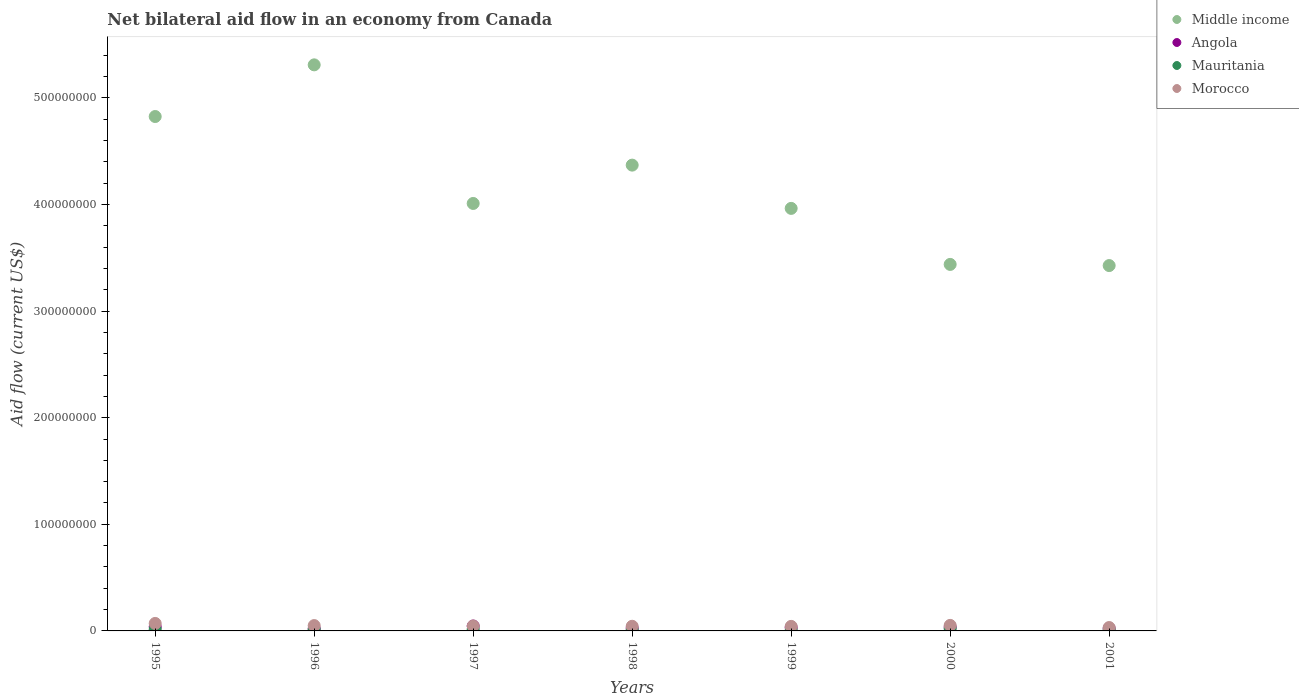What is the net bilateral aid flow in Morocco in 2001?
Your response must be concise. 3.18e+06. Across all years, what is the maximum net bilateral aid flow in Angola?
Your answer should be very brief. 4.59e+06. Across all years, what is the minimum net bilateral aid flow in Angola?
Your answer should be very brief. 2.17e+06. In which year was the net bilateral aid flow in Middle income maximum?
Make the answer very short. 1996. What is the total net bilateral aid flow in Angola in the graph?
Give a very brief answer. 2.23e+07. What is the difference between the net bilateral aid flow in Angola in 1995 and that in 2001?
Ensure brevity in your answer.  1.52e+06. What is the difference between the net bilateral aid flow in Morocco in 1997 and the net bilateral aid flow in Mauritania in 1995?
Offer a very short reply. 3.19e+06. What is the average net bilateral aid flow in Mauritania per year?
Keep it short and to the point. 1.25e+06. In the year 1995, what is the difference between the net bilateral aid flow in Morocco and net bilateral aid flow in Middle income?
Your answer should be compact. -4.75e+08. What is the ratio of the net bilateral aid flow in Middle income in 1997 to that in 2000?
Your answer should be compact. 1.17. Is the net bilateral aid flow in Angola in 1997 less than that in 2001?
Offer a very short reply. No. What is the difference between the highest and the second highest net bilateral aid flow in Middle income?
Your answer should be compact. 4.85e+07. What is the difference between the highest and the lowest net bilateral aid flow in Mauritania?
Provide a succinct answer. 1.61e+06. In how many years, is the net bilateral aid flow in Morocco greater than the average net bilateral aid flow in Morocco taken over all years?
Your answer should be very brief. 3. Is the sum of the net bilateral aid flow in Morocco in 1998 and 2001 greater than the maximum net bilateral aid flow in Angola across all years?
Give a very brief answer. Yes. Is it the case that in every year, the sum of the net bilateral aid flow in Morocco and net bilateral aid flow in Middle income  is greater than the net bilateral aid flow in Mauritania?
Give a very brief answer. Yes. Is the net bilateral aid flow in Middle income strictly greater than the net bilateral aid flow in Morocco over the years?
Give a very brief answer. Yes. How many dotlines are there?
Make the answer very short. 4. Are the values on the major ticks of Y-axis written in scientific E-notation?
Ensure brevity in your answer.  No. Does the graph contain any zero values?
Provide a short and direct response. No. Where does the legend appear in the graph?
Provide a short and direct response. Top right. How are the legend labels stacked?
Provide a succinct answer. Vertical. What is the title of the graph?
Keep it short and to the point. Net bilateral aid flow in an economy from Canada. Does "Spain" appear as one of the legend labels in the graph?
Provide a short and direct response. No. What is the label or title of the X-axis?
Provide a short and direct response. Years. What is the label or title of the Y-axis?
Offer a terse response. Aid flow (current US$). What is the Aid flow (current US$) in Middle income in 1995?
Your answer should be very brief. 4.82e+08. What is the Aid flow (current US$) of Angola in 1995?
Offer a very short reply. 3.84e+06. What is the Aid flow (current US$) of Mauritania in 1995?
Provide a short and direct response. 1.45e+06. What is the Aid flow (current US$) in Morocco in 1995?
Give a very brief answer. 7.02e+06. What is the Aid flow (current US$) in Middle income in 1996?
Give a very brief answer. 5.31e+08. What is the Aid flow (current US$) of Angola in 1996?
Provide a succinct answer. 2.17e+06. What is the Aid flow (current US$) in Mauritania in 1996?
Offer a terse response. 1.30e+06. What is the Aid flow (current US$) of Morocco in 1996?
Your response must be concise. 5.01e+06. What is the Aid flow (current US$) of Middle income in 1997?
Provide a short and direct response. 4.01e+08. What is the Aid flow (current US$) of Angola in 1997?
Your response must be concise. 4.59e+06. What is the Aid flow (current US$) in Mauritania in 1997?
Keep it short and to the point. 1.58e+06. What is the Aid flow (current US$) of Morocco in 1997?
Make the answer very short. 4.64e+06. What is the Aid flow (current US$) in Middle income in 1998?
Keep it short and to the point. 4.37e+08. What is the Aid flow (current US$) of Angola in 1998?
Offer a terse response. 2.63e+06. What is the Aid flow (current US$) in Mauritania in 1998?
Offer a very short reply. 8.80e+05. What is the Aid flow (current US$) of Morocco in 1998?
Keep it short and to the point. 4.36e+06. What is the Aid flow (current US$) of Middle income in 1999?
Make the answer very short. 3.96e+08. What is the Aid flow (current US$) in Angola in 1999?
Ensure brevity in your answer.  3.07e+06. What is the Aid flow (current US$) of Mauritania in 1999?
Offer a terse response. 4.90e+05. What is the Aid flow (current US$) of Morocco in 1999?
Provide a succinct answer. 4.26e+06. What is the Aid flow (current US$) of Middle income in 2000?
Give a very brief answer. 3.44e+08. What is the Aid flow (current US$) of Angola in 2000?
Offer a terse response. 3.64e+06. What is the Aid flow (current US$) of Mauritania in 2000?
Keep it short and to the point. 2.10e+06. What is the Aid flow (current US$) in Morocco in 2000?
Your answer should be compact. 5.19e+06. What is the Aid flow (current US$) of Middle income in 2001?
Provide a succinct answer. 3.43e+08. What is the Aid flow (current US$) in Angola in 2001?
Your answer should be compact. 2.32e+06. What is the Aid flow (current US$) in Mauritania in 2001?
Your response must be concise. 9.60e+05. What is the Aid flow (current US$) of Morocco in 2001?
Offer a terse response. 3.18e+06. Across all years, what is the maximum Aid flow (current US$) in Middle income?
Offer a terse response. 5.31e+08. Across all years, what is the maximum Aid flow (current US$) of Angola?
Ensure brevity in your answer.  4.59e+06. Across all years, what is the maximum Aid flow (current US$) in Mauritania?
Provide a succinct answer. 2.10e+06. Across all years, what is the maximum Aid flow (current US$) in Morocco?
Your answer should be compact. 7.02e+06. Across all years, what is the minimum Aid flow (current US$) in Middle income?
Your answer should be very brief. 3.43e+08. Across all years, what is the minimum Aid flow (current US$) of Angola?
Keep it short and to the point. 2.17e+06. Across all years, what is the minimum Aid flow (current US$) of Mauritania?
Your response must be concise. 4.90e+05. Across all years, what is the minimum Aid flow (current US$) of Morocco?
Provide a succinct answer. 3.18e+06. What is the total Aid flow (current US$) of Middle income in the graph?
Provide a succinct answer. 2.93e+09. What is the total Aid flow (current US$) in Angola in the graph?
Give a very brief answer. 2.23e+07. What is the total Aid flow (current US$) in Mauritania in the graph?
Provide a succinct answer. 8.76e+06. What is the total Aid flow (current US$) of Morocco in the graph?
Provide a short and direct response. 3.37e+07. What is the difference between the Aid flow (current US$) in Middle income in 1995 and that in 1996?
Provide a succinct answer. -4.85e+07. What is the difference between the Aid flow (current US$) of Angola in 1995 and that in 1996?
Offer a very short reply. 1.67e+06. What is the difference between the Aid flow (current US$) of Morocco in 1995 and that in 1996?
Make the answer very short. 2.01e+06. What is the difference between the Aid flow (current US$) of Middle income in 1995 and that in 1997?
Keep it short and to the point. 8.15e+07. What is the difference between the Aid flow (current US$) in Angola in 1995 and that in 1997?
Your answer should be compact. -7.50e+05. What is the difference between the Aid flow (current US$) in Mauritania in 1995 and that in 1997?
Offer a very short reply. -1.30e+05. What is the difference between the Aid flow (current US$) in Morocco in 1995 and that in 1997?
Your answer should be very brief. 2.38e+06. What is the difference between the Aid flow (current US$) of Middle income in 1995 and that in 1998?
Offer a very short reply. 4.56e+07. What is the difference between the Aid flow (current US$) in Angola in 1995 and that in 1998?
Provide a short and direct response. 1.21e+06. What is the difference between the Aid flow (current US$) of Mauritania in 1995 and that in 1998?
Give a very brief answer. 5.70e+05. What is the difference between the Aid flow (current US$) in Morocco in 1995 and that in 1998?
Offer a very short reply. 2.66e+06. What is the difference between the Aid flow (current US$) of Middle income in 1995 and that in 1999?
Your answer should be compact. 8.62e+07. What is the difference between the Aid flow (current US$) in Angola in 1995 and that in 1999?
Offer a very short reply. 7.70e+05. What is the difference between the Aid flow (current US$) in Mauritania in 1995 and that in 1999?
Offer a very short reply. 9.60e+05. What is the difference between the Aid flow (current US$) of Morocco in 1995 and that in 1999?
Your response must be concise. 2.76e+06. What is the difference between the Aid flow (current US$) in Middle income in 1995 and that in 2000?
Ensure brevity in your answer.  1.39e+08. What is the difference between the Aid flow (current US$) in Mauritania in 1995 and that in 2000?
Your answer should be compact. -6.50e+05. What is the difference between the Aid flow (current US$) in Morocco in 1995 and that in 2000?
Your answer should be very brief. 1.83e+06. What is the difference between the Aid flow (current US$) of Middle income in 1995 and that in 2001?
Your response must be concise. 1.40e+08. What is the difference between the Aid flow (current US$) in Angola in 1995 and that in 2001?
Offer a terse response. 1.52e+06. What is the difference between the Aid flow (current US$) of Mauritania in 1995 and that in 2001?
Your answer should be compact. 4.90e+05. What is the difference between the Aid flow (current US$) of Morocco in 1995 and that in 2001?
Your answer should be very brief. 3.84e+06. What is the difference between the Aid flow (current US$) in Middle income in 1996 and that in 1997?
Your answer should be compact. 1.30e+08. What is the difference between the Aid flow (current US$) of Angola in 1996 and that in 1997?
Your answer should be compact. -2.42e+06. What is the difference between the Aid flow (current US$) of Mauritania in 1996 and that in 1997?
Ensure brevity in your answer.  -2.80e+05. What is the difference between the Aid flow (current US$) of Morocco in 1996 and that in 1997?
Your response must be concise. 3.70e+05. What is the difference between the Aid flow (current US$) of Middle income in 1996 and that in 1998?
Keep it short and to the point. 9.40e+07. What is the difference between the Aid flow (current US$) of Angola in 1996 and that in 1998?
Provide a succinct answer. -4.60e+05. What is the difference between the Aid flow (current US$) in Morocco in 1996 and that in 1998?
Make the answer very short. 6.50e+05. What is the difference between the Aid flow (current US$) of Middle income in 1996 and that in 1999?
Provide a short and direct response. 1.35e+08. What is the difference between the Aid flow (current US$) of Angola in 1996 and that in 1999?
Your response must be concise. -9.00e+05. What is the difference between the Aid flow (current US$) of Mauritania in 1996 and that in 1999?
Offer a very short reply. 8.10e+05. What is the difference between the Aid flow (current US$) in Morocco in 1996 and that in 1999?
Your answer should be very brief. 7.50e+05. What is the difference between the Aid flow (current US$) of Middle income in 1996 and that in 2000?
Make the answer very short. 1.87e+08. What is the difference between the Aid flow (current US$) in Angola in 1996 and that in 2000?
Offer a very short reply. -1.47e+06. What is the difference between the Aid flow (current US$) of Mauritania in 1996 and that in 2000?
Offer a very short reply. -8.00e+05. What is the difference between the Aid flow (current US$) of Middle income in 1996 and that in 2001?
Your answer should be very brief. 1.88e+08. What is the difference between the Aid flow (current US$) of Mauritania in 1996 and that in 2001?
Your response must be concise. 3.40e+05. What is the difference between the Aid flow (current US$) of Morocco in 1996 and that in 2001?
Make the answer very short. 1.83e+06. What is the difference between the Aid flow (current US$) in Middle income in 1997 and that in 1998?
Provide a succinct answer. -3.60e+07. What is the difference between the Aid flow (current US$) of Angola in 1997 and that in 1998?
Your answer should be compact. 1.96e+06. What is the difference between the Aid flow (current US$) of Morocco in 1997 and that in 1998?
Give a very brief answer. 2.80e+05. What is the difference between the Aid flow (current US$) in Middle income in 1997 and that in 1999?
Offer a very short reply. 4.63e+06. What is the difference between the Aid flow (current US$) of Angola in 1997 and that in 1999?
Keep it short and to the point. 1.52e+06. What is the difference between the Aid flow (current US$) of Mauritania in 1997 and that in 1999?
Your answer should be very brief. 1.09e+06. What is the difference between the Aid flow (current US$) of Morocco in 1997 and that in 1999?
Offer a terse response. 3.80e+05. What is the difference between the Aid flow (current US$) of Middle income in 1997 and that in 2000?
Keep it short and to the point. 5.72e+07. What is the difference between the Aid flow (current US$) in Angola in 1997 and that in 2000?
Your answer should be very brief. 9.50e+05. What is the difference between the Aid flow (current US$) of Mauritania in 1997 and that in 2000?
Your answer should be compact. -5.20e+05. What is the difference between the Aid flow (current US$) of Morocco in 1997 and that in 2000?
Provide a succinct answer. -5.50e+05. What is the difference between the Aid flow (current US$) of Middle income in 1997 and that in 2001?
Offer a terse response. 5.83e+07. What is the difference between the Aid flow (current US$) of Angola in 1997 and that in 2001?
Provide a short and direct response. 2.27e+06. What is the difference between the Aid flow (current US$) in Mauritania in 1997 and that in 2001?
Offer a terse response. 6.20e+05. What is the difference between the Aid flow (current US$) in Morocco in 1997 and that in 2001?
Give a very brief answer. 1.46e+06. What is the difference between the Aid flow (current US$) of Middle income in 1998 and that in 1999?
Make the answer very short. 4.06e+07. What is the difference between the Aid flow (current US$) of Angola in 1998 and that in 1999?
Offer a very short reply. -4.40e+05. What is the difference between the Aid flow (current US$) of Middle income in 1998 and that in 2000?
Provide a short and direct response. 9.31e+07. What is the difference between the Aid flow (current US$) in Angola in 1998 and that in 2000?
Provide a short and direct response. -1.01e+06. What is the difference between the Aid flow (current US$) in Mauritania in 1998 and that in 2000?
Your answer should be very brief. -1.22e+06. What is the difference between the Aid flow (current US$) in Morocco in 1998 and that in 2000?
Provide a succinct answer. -8.30e+05. What is the difference between the Aid flow (current US$) of Middle income in 1998 and that in 2001?
Make the answer very short. 9.42e+07. What is the difference between the Aid flow (current US$) in Morocco in 1998 and that in 2001?
Your answer should be very brief. 1.18e+06. What is the difference between the Aid flow (current US$) in Middle income in 1999 and that in 2000?
Provide a succinct answer. 5.26e+07. What is the difference between the Aid flow (current US$) in Angola in 1999 and that in 2000?
Provide a short and direct response. -5.70e+05. What is the difference between the Aid flow (current US$) in Mauritania in 1999 and that in 2000?
Make the answer very short. -1.61e+06. What is the difference between the Aid flow (current US$) of Morocco in 1999 and that in 2000?
Ensure brevity in your answer.  -9.30e+05. What is the difference between the Aid flow (current US$) in Middle income in 1999 and that in 2001?
Your answer should be very brief. 5.36e+07. What is the difference between the Aid flow (current US$) of Angola in 1999 and that in 2001?
Your answer should be compact. 7.50e+05. What is the difference between the Aid flow (current US$) of Mauritania in 1999 and that in 2001?
Ensure brevity in your answer.  -4.70e+05. What is the difference between the Aid flow (current US$) of Morocco in 1999 and that in 2001?
Provide a short and direct response. 1.08e+06. What is the difference between the Aid flow (current US$) of Middle income in 2000 and that in 2001?
Offer a terse response. 1.08e+06. What is the difference between the Aid flow (current US$) in Angola in 2000 and that in 2001?
Offer a terse response. 1.32e+06. What is the difference between the Aid flow (current US$) in Mauritania in 2000 and that in 2001?
Offer a very short reply. 1.14e+06. What is the difference between the Aid flow (current US$) of Morocco in 2000 and that in 2001?
Your answer should be compact. 2.01e+06. What is the difference between the Aid flow (current US$) of Middle income in 1995 and the Aid flow (current US$) of Angola in 1996?
Provide a succinct answer. 4.80e+08. What is the difference between the Aid flow (current US$) of Middle income in 1995 and the Aid flow (current US$) of Mauritania in 1996?
Give a very brief answer. 4.81e+08. What is the difference between the Aid flow (current US$) in Middle income in 1995 and the Aid flow (current US$) in Morocco in 1996?
Provide a short and direct response. 4.77e+08. What is the difference between the Aid flow (current US$) of Angola in 1995 and the Aid flow (current US$) of Mauritania in 1996?
Keep it short and to the point. 2.54e+06. What is the difference between the Aid flow (current US$) in Angola in 1995 and the Aid flow (current US$) in Morocco in 1996?
Give a very brief answer. -1.17e+06. What is the difference between the Aid flow (current US$) of Mauritania in 1995 and the Aid flow (current US$) of Morocco in 1996?
Keep it short and to the point. -3.56e+06. What is the difference between the Aid flow (current US$) of Middle income in 1995 and the Aid flow (current US$) of Angola in 1997?
Your response must be concise. 4.78e+08. What is the difference between the Aid flow (current US$) in Middle income in 1995 and the Aid flow (current US$) in Mauritania in 1997?
Your answer should be very brief. 4.81e+08. What is the difference between the Aid flow (current US$) in Middle income in 1995 and the Aid flow (current US$) in Morocco in 1997?
Your answer should be compact. 4.78e+08. What is the difference between the Aid flow (current US$) of Angola in 1995 and the Aid flow (current US$) of Mauritania in 1997?
Your answer should be compact. 2.26e+06. What is the difference between the Aid flow (current US$) of Angola in 1995 and the Aid flow (current US$) of Morocco in 1997?
Give a very brief answer. -8.00e+05. What is the difference between the Aid flow (current US$) of Mauritania in 1995 and the Aid flow (current US$) of Morocco in 1997?
Keep it short and to the point. -3.19e+06. What is the difference between the Aid flow (current US$) of Middle income in 1995 and the Aid flow (current US$) of Angola in 1998?
Offer a terse response. 4.80e+08. What is the difference between the Aid flow (current US$) of Middle income in 1995 and the Aid flow (current US$) of Mauritania in 1998?
Make the answer very short. 4.82e+08. What is the difference between the Aid flow (current US$) in Middle income in 1995 and the Aid flow (current US$) in Morocco in 1998?
Keep it short and to the point. 4.78e+08. What is the difference between the Aid flow (current US$) in Angola in 1995 and the Aid flow (current US$) in Mauritania in 1998?
Keep it short and to the point. 2.96e+06. What is the difference between the Aid flow (current US$) in Angola in 1995 and the Aid flow (current US$) in Morocco in 1998?
Provide a succinct answer. -5.20e+05. What is the difference between the Aid flow (current US$) in Mauritania in 1995 and the Aid flow (current US$) in Morocco in 1998?
Make the answer very short. -2.91e+06. What is the difference between the Aid flow (current US$) of Middle income in 1995 and the Aid flow (current US$) of Angola in 1999?
Provide a short and direct response. 4.79e+08. What is the difference between the Aid flow (current US$) of Middle income in 1995 and the Aid flow (current US$) of Mauritania in 1999?
Keep it short and to the point. 4.82e+08. What is the difference between the Aid flow (current US$) of Middle income in 1995 and the Aid flow (current US$) of Morocco in 1999?
Provide a short and direct response. 4.78e+08. What is the difference between the Aid flow (current US$) of Angola in 1995 and the Aid flow (current US$) of Mauritania in 1999?
Provide a succinct answer. 3.35e+06. What is the difference between the Aid flow (current US$) of Angola in 1995 and the Aid flow (current US$) of Morocco in 1999?
Give a very brief answer. -4.20e+05. What is the difference between the Aid flow (current US$) in Mauritania in 1995 and the Aid flow (current US$) in Morocco in 1999?
Offer a terse response. -2.81e+06. What is the difference between the Aid flow (current US$) of Middle income in 1995 and the Aid flow (current US$) of Angola in 2000?
Provide a short and direct response. 4.79e+08. What is the difference between the Aid flow (current US$) of Middle income in 1995 and the Aid flow (current US$) of Mauritania in 2000?
Offer a very short reply. 4.80e+08. What is the difference between the Aid flow (current US$) of Middle income in 1995 and the Aid flow (current US$) of Morocco in 2000?
Give a very brief answer. 4.77e+08. What is the difference between the Aid flow (current US$) of Angola in 1995 and the Aid flow (current US$) of Mauritania in 2000?
Give a very brief answer. 1.74e+06. What is the difference between the Aid flow (current US$) of Angola in 1995 and the Aid flow (current US$) of Morocco in 2000?
Provide a succinct answer. -1.35e+06. What is the difference between the Aid flow (current US$) in Mauritania in 1995 and the Aid flow (current US$) in Morocco in 2000?
Ensure brevity in your answer.  -3.74e+06. What is the difference between the Aid flow (current US$) in Middle income in 1995 and the Aid flow (current US$) in Angola in 2001?
Your response must be concise. 4.80e+08. What is the difference between the Aid flow (current US$) of Middle income in 1995 and the Aid flow (current US$) of Mauritania in 2001?
Your answer should be compact. 4.82e+08. What is the difference between the Aid flow (current US$) of Middle income in 1995 and the Aid flow (current US$) of Morocco in 2001?
Offer a very short reply. 4.79e+08. What is the difference between the Aid flow (current US$) of Angola in 1995 and the Aid flow (current US$) of Mauritania in 2001?
Offer a terse response. 2.88e+06. What is the difference between the Aid flow (current US$) in Angola in 1995 and the Aid flow (current US$) in Morocco in 2001?
Your answer should be very brief. 6.60e+05. What is the difference between the Aid flow (current US$) of Mauritania in 1995 and the Aid flow (current US$) of Morocco in 2001?
Keep it short and to the point. -1.73e+06. What is the difference between the Aid flow (current US$) of Middle income in 1996 and the Aid flow (current US$) of Angola in 1997?
Your answer should be compact. 5.26e+08. What is the difference between the Aid flow (current US$) of Middle income in 1996 and the Aid flow (current US$) of Mauritania in 1997?
Provide a short and direct response. 5.29e+08. What is the difference between the Aid flow (current US$) in Middle income in 1996 and the Aid flow (current US$) in Morocco in 1997?
Ensure brevity in your answer.  5.26e+08. What is the difference between the Aid flow (current US$) in Angola in 1996 and the Aid flow (current US$) in Mauritania in 1997?
Offer a terse response. 5.90e+05. What is the difference between the Aid flow (current US$) in Angola in 1996 and the Aid flow (current US$) in Morocco in 1997?
Provide a short and direct response. -2.47e+06. What is the difference between the Aid flow (current US$) of Mauritania in 1996 and the Aid flow (current US$) of Morocco in 1997?
Ensure brevity in your answer.  -3.34e+06. What is the difference between the Aid flow (current US$) of Middle income in 1996 and the Aid flow (current US$) of Angola in 1998?
Offer a very short reply. 5.28e+08. What is the difference between the Aid flow (current US$) of Middle income in 1996 and the Aid flow (current US$) of Mauritania in 1998?
Ensure brevity in your answer.  5.30e+08. What is the difference between the Aid flow (current US$) of Middle income in 1996 and the Aid flow (current US$) of Morocco in 1998?
Give a very brief answer. 5.27e+08. What is the difference between the Aid flow (current US$) in Angola in 1996 and the Aid flow (current US$) in Mauritania in 1998?
Offer a terse response. 1.29e+06. What is the difference between the Aid flow (current US$) of Angola in 1996 and the Aid flow (current US$) of Morocco in 1998?
Make the answer very short. -2.19e+06. What is the difference between the Aid flow (current US$) in Mauritania in 1996 and the Aid flow (current US$) in Morocco in 1998?
Provide a short and direct response. -3.06e+06. What is the difference between the Aid flow (current US$) in Middle income in 1996 and the Aid flow (current US$) in Angola in 1999?
Give a very brief answer. 5.28e+08. What is the difference between the Aid flow (current US$) of Middle income in 1996 and the Aid flow (current US$) of Mauritania in 1999?
Give a very brief answer. 5.30e+08. What is the difference between the Aid flow (current US$) in Middle income in 1996 and the Aid flow (current US$) in Morocco in 1999?
Ensure brevity in your answer.  5.27e+08. What is the difference between the Aid flow (current US$) of Angola in 1996 and the Aid flow (current US$) of Mauritania in 1999?
Offer a very short reply. 1.68e+06. What is the difference between the Aid flow (current US$) of Angola in 1996 and the Aid flow (current US$) of Morocco in 1999?
Offer a very short reply. -2.09e+06. What is the difference between the Aid flow (current US$) of Mauritania in 1996 and the Aid flow (current US$) of Morocco in 1999?
Make the answer very short. -2.96e+06. What is the difference between the Aid flow (current US$) in Middle income in 1996 and the Aid flow (current US$) in Angola in 2000?
Ensure brevity in your answer.  5.27e+08. What is the difference between the Aid flow (current US$) of Middle income in 1996 and the Aid flow (current US$) of Mauritania in 2000?
Ensure brevity in your answer.  5.29e+08. What is the difference between the Aid flow (current US$) of Middle income in 1996 and the Aid flow (current US$) of Morocco in 2000?
Ensure brevity in your answer.  5.26e+08. What is the difference between the Aid flow (current US$) of Angola in 1996 and the Aid flow (current US$) of Morocco in 2000?
Your response must be concise. -3.02e+06. What is the difference between the Aid flow (current US$) of Mauritania in 1996 and the Aid flow (current US$) of Morocco in 2000?
Offer a terse response. -3.89e+06. What is the difference between the Aid flow (current US$) in Middle income in 1996 and the Aid flow (current US$) in Angola in 2001?
Keep it short and to the point. 5.29e+08. What is the difference between the Aid flow (current US$) of Middle income in 1996 and the Aid flow (current US$) of Mauritania in 2001?
Your answer should be very brief. 5.30e+08. What is the difference between the Aid flow (current US$) of Middle income in 1996 and the Aid flow (current US$) of Morocco in 2001?
Provide a short and direct response. 5.28e+08. What is the difference between the Aid flow (current US$) of Angola in 1996 and the Aid flow (current US$) of Mauritania in 2001?
Your answer should be compact. 1.21e+06. What is the difference between the Aid flow (current US$) in Angola in 1996 and the Aid flow (current US$) in Morocco in 2001?
Give a very brief answer. -1.01e+06. What is the difference between the Aid flow (current US$) in Mauritania in 1996 and the Aid flow (current US$) in Morocco in 2001?
Your response must be concise. -1.88e+06. What is the difference between the Aid flow (current US$) in Middle income in 1997 and the Aid flow (current US$) in Angola in 1998?
Offer a very short reply. 3.98e+08. What is the difference between the Aid flow (current US$) in Middle income in 1997 and the Aid flow (current US$) in Mauritania in 1998?
Provide a succinct answer. 4.00e+08. What is the difference between the Aid flow (current US$) in Middle income in 1997 and the Aid flow (current US$) in Morocco in 1998?
Offer a terse response. 3.97e+08. What is the difference between the Aid flow (current US$) in Angola in 1997 and the Aid flow (current US$) in Mauritania in 1998?
Keep it short and to the point. 3.71e+06. What is the difference between the Aid flow (current US$) in Angola in 1997 and the Aid flow (current US$) in Morocco in 1998?
Your response must be concise. 2.30e+05. What is the difference between the Aid flow (current US$) in Mauritania in 1997 and the Aid flow (current US$) in Morocco in 1998?
Provide a short and direct response. -2.78e+06. What is the difference between the Aid flow (current US$) in Middle income in 1997 and the Aid flow (current US$) in Angola in 1999?
Give a very brief answer. 3.98e+08. What is the difference between the Aid flow (current US$) of Middle income in 1997 and the Aid flow (current US$) of Mauritania in 1999?
Offer a terse response. 4.00e+08. What is the difference between the Aid flow (current US$) of Middle income in 1997 and the Aid flow (current US$) of Morocco in 1999?
Provide a succinct answer. 3.97e+08. What is the difference between the Aid flow (current US$) in Angola in 1997 and the Aid flow (current US$) in Mauritania in 1999?
Offer a very short reply. 4.10e+06. What is the difference between the Aid flow (current US$) in Angola in 1997 and the Aid flow (current US$) in Morocco in 1999?
Your answer should be compact. 3.30e+05. What is the difference between the Aid flow (current US$) in Mauritania in 1997 and the Aid flow (current US$) in Morocco in 1999?
Your answer should be very brief. -2.68e+06. What is the difference between the Aid flow (current US$) in Middle income in 1997 and the Aid flow (current US$) in Angola in 2000?
Your answer should be very brief. 3.97e+08. What is the difference between the Aid flow (current US$) in Middle income in 1997 and the Aid flow (current US$) in Mauritania in 2000?
Provide a succinct answer. 3.99e+08. What is the difference between the Aid flow (current US$) in Middle income in 1997 and the Aid flow (current US$) in Morocco in 2000?
Offer a very short reply. 3.96e+08. What is the difference between the Aid flow (current US$) in Angola in 1997 and the Aid flow (current US$) in Mauritania in 2000?
Provide a succinct answer. 2.49e+06. What is the difference between the Aid flow (current US$) in Angola in 1997 and the Aid flow (current US$) in Morocco in 2000?
Offer a terse response. -6.00e+05. What is the difference between the Aid flow (current US$) of Mauritania in 1997 and the Aid flow (current US$) of Morocco in 2000?
Your response must be concise. -3.61e+06. What is the difference between the Aid flow (current US$) in Middle income in 1997 and the Aid flow (current US$) in Angola in 2001?
Ensure brevity in your answer.  3.99e+08. What is the difference between the Aid flow (current US$) in Middle income in 1997 and the Aid flow (current US$) in Mauritania in 2001?
Keep it short and to the point. 4.00e+08. What is the difference between the Aid flow (current US$) of Middle income in 1997 and the Aid flow (current US$) of Morocco in 2001?
Your answer should be very brief. 3.98e+08. What is the difference between the Aid flow (current US$) of Angola in 1997 and the Aid flow (current US$) of Mauritania in 2001?
Your answer should be compact. 3.63e+06. What is the difference between the Aid flow (current US$) of Angola in 1997 and the Aid flow (current US$) of Morocco in 2001?
Offer a terse response. 1.41e+06. What is the difference between the Aid flow (current US$) of Mauritania in 1997 and the Aid flow (current US$) of Morocco in 2001?
Make the answer very short. -1.60e+06. What is the difference between the Aid flow (current US$) of Middle income in 1998 and the Aid flow (current US$) of Angola in 1999?
Keep it short and to the point. 4.34e+08. What is the difference between the Aid flow (current US$) in Middle income in 1998 and the Aid flow (current US$) in Mauritania in 1999?
Provide a short and direct response. 4.36e+08. What is the difference between the Aid flow (current US$) of Middle income in 1998 and the Aid flow (current US$) of Morocco in 1999?
Your response must be concise. 4.33e+08. What is the difference between the Aid flow (current US$) in Angola in 1998 and the Aid flow (current US$) in Mauritania in 1999?
Ensure brevity in your answer.  2.14e+06. What is the difference between the Aid flow (current US$) of Angola in 1998 and the Aid flow (current US$) of Morocco in 1999?
Provide a succinct answer. -1.63e+06. What is the difference between the Aid flow (current US$) in Mauritania in 1998 and the Aid flow (current US$) in Morocco in 1999?
Provide a succinct answer. -3.38e+06. What is the difference between the Aid flow (current US$) in Middle income in 1998 and the Aid flow (current US$) in Angola in 2000?
Keep it short and to the point. 4.33e+08. What is the difference between the Aid flow (current US$) of Middle income in 1998 and the Aid flow (current US$) of Mauritania in 2000?
Ensure brevity in your answer.  4.35e+08. What is the difference between the Aid flow (current US$) in Middle income in 1998 and the Aid flow (current US$) in Morocco in 2000?
Your answer should be compact. 4.32e+08. What is the difference between the Aid flow (current US$) of Angola in 1998 and the Aid flow (current US$) of Mauritania in 2000?
Provide a succinct answer. 5.30e+05. What is the difference between the Aid flow (current US$) of Angola in 1998 and the Aid flow (current US$) of Morocco in 2000?
Give a very brief answer. -2.56e+06. What is the difference between the Aid flow (current US$) of Mauritania in 1998 and the Aid flow (current US$) of Morocco in 2000?
Offer a terse response. -4.31e+06. What is the difference between the Aid flow (current US$) of Middle income in 1998 and the Aid flow (current US$) of Angola in 2001?
Offer a very short reply. 4.35e+08. What is the difference between the Aid flow (current US$) of Middle income in 1998 and the Aid flow (current US$) of Mauritania in 2001?
Offer a very short reply. 4.36e+08. What is the difference between the Aid flow (current US$) of Middle income in 1998 and the Aid flow (current US$) of Morocco in 2001?
Provide a succinct answer. 4.34e+08. What is the difference between the Aid flow (current US$) in Angola in 1998 and the Aid flow (current US$) in Mauritania in 2001?
Ensure brevity in your answer.  1.67e+06. What is the difference between the Aid flow (current US$) in Angola in 1998 and the Aid flow (current US$) in Morocco in 2001?
Your response must be concise. -5.50e+05. What is the difference between the Aid flow (current US$) in Mauritania in 1998 and the Aid flow (current US$) in Morocco in 2001?
Offer a terse response. -2.30e+06. What is the difference between the Aid flow (current US$) of Middle income in 1999 and the Aid flow (current US$) of Angola in 2000?
Give a very brief answer. 3.93e+08. What is the difference between the Aid flow (current US$) in Middle income in 1999 and the Aid flow (current US$) in Mauritania in 2000?
Give a very brief answer. 3.94e+08. What is the difference between the Aid flow (current US$) of Middle income in 1999 and the Aid flow (current US$) of Morocco in 2000?
Your response must be concise. 3.91e+08. What is the difference between the Aid flow (current US$) of Angola in 1999 and the Aid flow (current US$) of Mauritania in 2000?
Offer a terse response. 9.70e+05. What is the difference between the Aid flow (current US$) of Angola in 1999 and the Aid flow (current US$) of Morocco in 2000?
Offer a terse response. -2.12e+06. What is the difference between the Aid flow (current US$) of Mauritania in 1999 and the Aid flow (current US$) of Morocco in 2000?
Offer a very short reply. -4.70e+06. What is the difference between the Aid flow (current US$) in Middle income in 1999 and the Aid flow (current US$) in Angola in 2001?
Provide a succinct answer. 3.94e+08. What is the difference between the Aid flow (current US$) in Middle income in 1999 and the Aid flow (current US$) in Mauritania in 2001?
Your response must be concise. 3.95e+08. What is the difference between the Aid flow (current US$) of Middle income in 1999 and the Aid flow (current US$) of Morocco in 2001?
Your answer should be very brief. 3.93e+08. What is the difference between the Aid flow (current US$) in Angola in 1999 and the Aid flow (current US$) in Mauritania in 2001?
Offer a very short reply. 2.11e+06. What is the difference between the Aid flow (current US$) of Mauritania in 1999 and the Aid flow (current US$) of Morocco in 2001?
Offer a very short reply. -2.69e+06. What is the difference between the Aid flow (current US$) in Middle income in 2000 and the Aid flow (current US$) in Angola in 2001?
Your response must be concise. 3.41e+08. What is the difference between the Aid flow (current US$) in Middle income in 2000 and the Aid flow (current US$) in Mauritania in 2001?
Offer a very short reply. 3.43e+08. What is the difference between the Aid flow (current US$) in Middle income in 2000 and the Aid flow (current US$) in Morocco in 2001?
Your answer should be compact. 3.41e+08. What is the difference between the Aid flow (current US$) in Angola in 2000 and the Aid flow (current US$) in Mauritania in 2001?
Your answer should be very brief. 2.68e+06. What is the difference between the Aid flow (current US$) in Angola in 2000 and the Aid flow (current US$) in Morocco in 2001?
Provide a succinct answer. 4.60e+05. What is the difference between the Aid flow (current US$) of Mauritania in 2000 and the Aid flow (current US$) of Morocco in 2001?
Your response must be concise. -1.08e+06. What is the average Aid flow (current US$) in Middle income per year?
Your answer should be very brief. 4.19e+08. What is the average Aid flow (current US$) of Angola per year?
Provide a succinct answer. 3.18e+06. What is the average Aid flow (current US$) of Mauritania per year?
Provide a succinct answer. 1.25e+06. What is the average Aid flow (current US$) of Morocco per year?
Your answer should be very brief. 4.81e+06. In the year 1995, what is the difference between the Aid flow (current US$) in Middle income and Aid flow (current US$) in Angola?
Give a very brief answer. 4.79e+08. In the year 1995, what is the difference between the Aid flow (current US$) in Middle income and Aid flow (current US$) in Mauritania?
Offer a very short reply. 4.81e+08. In the year 1995, what is the difference between the Aid flow (current US$) in Middle income and Aid flow (current US$) in Morocco?
Make the answer very short. 4.75e+08. In the year 1995, what is the difference between the Aid flow (current US$) in Angola and Aid flow (current US$) in Mauritania?
Your answer should be very brief. 2.39e+06. In the year 1995, what is the difference between the Aid flow (current US$) in Angola and Aid flow (current US$) in Morocco?
Give a very brief answer. -3.18e+06. In the year 1995, what is the difference between the Aid flow (current US$) in Mauritania and Aid flow (current US$) in Morocco?
Your response must be concise. -5.57e+06. In the year 1996, what is the difference between the Aid flow (current US$) in Middle income and Aid flow (current US$) in Angola?
Your response must be concise. 5.29e+08. In the year 1996, what is the difference between the Aid flow (current US$) in Middle income and Aid flow (current US$) in Mauritania?
Keep it short and to the point. 5.30e+08. In the year 1996, what is the difference between the Aid flow (current US$) of Middle income and Aid flow (current US$) of Morocco?
Your response must be concise. 5.26e+08. In the year 1996, what is the difference between the Aid flow (current US$) of Angola and Aid flow (current US$) of Mauritania?
Your answer should be very brief. 8.70e+05. In the year 1996, what is the difference between the Aid flow (current US$) of Angola and Aid flow (current US$) of Morocco?
Give a very brief answer. -2.84e+06. In the year 1996, what is the difference between the Aid flow (current US$) of Mauritania and Aid flow (current US$) of Morocco?
Your answer should be compact. -3.71e+06. In the year 1997, what is the difference between the Aid flow (current US$) of Middle income and Aid flow (current US$) of Angola?
Offer a very short reply. 3.96e+08. In the year 1997, what is the difference between the Aid flow (current US$) in Middle income and Aid flow (current US$) in Mauritania?
Your answer should be very brief. 3.99e+08. In the year 1997, what is the difference between the Aid flow (current US$) in Middle income and Aid flow (current US$) in Morocco?
Ensure brevity in your answer.  3.96e+08. In the year 1997, what is the difference between the Aid flow (current US$) in Angola and Aid flow (current US$) in Mauritania?
Give a very brief answer. 3.01e+06. In the year 1997, what is the difference between the Aid flow (current US$) in Mauritania and Aid flow (current US$) in Morocco?
Your response must be concise. -3.06e+06. In the year 1998, what is the difference between the Aid flow (current US$) of Middle income and Aid flow (current US$) of Angola?
Your answer should be very brief. 4.34e+08. In the year 1998, what is the difference between the Aid flow (current US$) of Middle income and Aid flow (current US$) of Mauritania?
Offer a very short reply. 4.36e+08. In the year 1998, what is the difference between the Aid flow (current US$) in Middle income and Aid flow (current US$) in Morocco?
Give a very brief answer. 4.33e+08. In the year 1998, what is the difference between the Aid flow (current US$) in Angola and Aid flow (current US$) in Mauritania?
Provide a short and direct response. 1.75e+06. In the year 1998, what is the difference between the Aid flow (current US$) of Angola and Aid flow (current US$) of Morocco?
Keep it short and to the point. -1.73e+06. In the year 1998, what is the difference between the Aid flow (current US$) of Mauritania and Aid flow (current US$) of Morocco?
Offer a very short reply. -3.48e+06. In the year 1999, what is the difference between the Aid flow (current US$) of Middle income and Aid flow (current US$) of Angola?
Offer a very short reply. 3.93e+08. In the year 1999, what is the difference between the Aid flow (current US$) of Middle income and Aid flow (current US$) of Mauritania?
Ensure brevity in your answer.  3.96e+08. In the year 1999, what is the difference between the Aid flow (current US$) in Middle income and Aid flow (current US$) in Morocco?
Make the answer very short. 3.92e+08. In the year 1999, what is the difference between the Aid flow (current US$) of Angola and Aid flow (current US$) of Mauritania?
Provide a short and direct response. 2.58e+06. In the year 1999, what is the difference between the Aid flow (current US$) of Angola and Aid flow (current US$) of Morocco?
Offer a very short reply. -1.19e+06. In the year 1999, what is the difference between the Aid flow (current US$) of Mauritania and Aid flow (current US$) of Morocco?
Offer a very short reply. -3.77e+06. In the year 2000, what is the difference between the Aid flow (current US$) of Middle income and Aid flow (current US$) of Angola?
Provide a succinct answer. 3.40e+08. In the year 2000, what is the difference between the Aid flow (current US$) of Middle income and Aid flow (current US$) of Mauritania?
Offer a terse response. 3.42e+08. In the year 2000, what is the difference between the Aid flow (current US$) in Middle income and Aid flow (current US$) in Morocco?
Provide a succinct answer. 3.39e+08. In the year 2000, what is the difference between the Aid flow (current US$) of Angola and Aid flow (current US$) of Mauritania?
Ensure brevity in your answer.  1.54e+06. In the year 2000, what is the difference between the Aid flow (current US$) in Angola and Aid flow (current US$) in Morocco?
Give a very brief answer. -1.55e+06. In the year 2000, what is the difference between the Aid flow (current US$) of Mauritania and Aid flow (current US$) of Morocco?
Provide a short and direct response. -3.09e+06. In the year 2001, what is the difference between the Aid flow (current US$) of Middle income and Aid flow (current US$) of Angola?
Your answer should be very brief. 3.40e+08. In the year 2001, what is the difference between the Aid flow (current US$) of Middle income and Aid flow (current US$) of Mauritania?
Provide a short and direct response. 3.42e+08. In the year 2001, what is the difference between the Aid flow (current US$) of Middle income and Aid flow (current US$) of Morocco?
Provide a short and direct response. 3.40e+08. In the year 2001, what is the difference between the Aid flow (current US$) in Angola and Aid flow (current US$) in Mauritania?
Offer a very short reply. 1.36e+06. In the year 2001, what is the difference between the Aid flow (current US$) in Angola and Aid flow (current US$) in Morocco?
Make the answer very short. -8.60e+05. In the year 2001, what is the difference between the Aid flow (current US$) in Mauritania and Aid flow (current US$) in Morocco?
Ensure brevity in your answer.  -2.22e+06. What is the ratio of the Aid flow (current US$) of Middle income in 1995 to that in 1996?
Your response must be concise. 0.91. What is the ratio of the Aid flow (current US$) in Angola in 1995 to that in 1996?
Make the answer very short. 1.77. What is the ratio of the Aid flow (current US$) of Mauritania in 1995 to that in 1996?
Your response must be concise. 1.12. What is the ratio of the Aid flow (current US$) of Morocco in 1995 to that in 1996?
Offer a very short reply. 1.4. What is the ratio of the Aid flow (current US$) in Middle income in 1995 to that in 1997?
Your response must be concise. 1.2. What is the ratio of the Aid flow (current US$) in Angola in 1995 to that in 1997?
Make the answer very short. 0.84. What is the ratio of the Aid flow (current US$) of Mauritania in 1995 to that in 1997?
Offer a very short reply. 0.92. What is the ratio of the Aid flow (current US$) of Morocco in 1995 to that in 1997?
Give a very brief answer. 1.51. What is the ratio of the Aid flow (current US$) in Middle income in 1995 to that in 1998?
Your answer should be very brief. 1.1. What is the ratio of the Aid flow (current US$) in Angola in 1995 to that in 1998?
Make the answer very short. 1.46. What is the ratio of the Aid flow (current US$) in Mauritania in 1995 to that in 1998?
Make the answer very short. 1.65. What is the ratio of the Aid flow (current US$) in Morocco in 1995 to that in 1998?
Offer a terse response. 1.61. What is the ratio of the Aid flow (current US$) of Middle income in 1995 to that in 1999?
Keep it short and to the point. 1.22. What is the ratio of the Aid flow (current US$) of Angola in 1995 to that in 1999?
Keep it short and to the point. 1.25. What is the ratio of the Aid flow (current US$) in Mauritania in 1995 to that in 1999?
Give a very brief answer. 2.96. What is the ratio of the Aid flow (current US$) in Morocco in 1995 to that in 1999?
Make the answer very short. 1.65. What is the ratio of the Aid flow (current US$) in Middle income in 1995 to that in 2000?
Provide a short and direct response. 1.4. What is the ratio of the Aid flow (current US$) in Angola in 1995 to that in 2000?
Keep it short and to the point. 1.05. What is the ratio of the Aid flow (current US$) in Mauritania in 1995 to that in 2000?
Your answer should be compact. 0.69. What is the ratio of the Aid flow (current US$) of Morocco in 1995 to that in 2000?
Make the answer very short. 1.35. What is the ratio of the Aid flow (current US$) of Middle income in 1995 to that in 2001?
Provide a succinct answer. 1.41. What is the ratio of the Aid flow (current US$) of Angola in 1995 to that in 2001?
Your answer should be compact. 1.66. What is the ratio of the Aid flow (current US$) in Mauritania in 1995 to that in 2001?
Your answer should be compact. 1.51. What is the ratio of the Aid flow (current US$) of Morocco in 1995 to that in 2001?
Ensure brevity in your answer.  2.21. What is the ratio of the Aid flow (current US$) in Middle income in 1996 to that in 1997?
Offer a very short reply. 1.32. What is the ratio of the Aid flow (current US$) in Angola in 1996 to that in 1997?
Keep it short and to the point. 0.47. What is the ratio of the Aid flow (current US$) of Mauritania in 1996 to that in 1997?
Ensure brevity in your answer.  0.82. What is the ratio of the Aid flow (current US$) in Morocco in 1996 to that in 1997?
Your response must be concise. 1.08. What is the ratio of the Aid flow (current US$) of Middle income in 1996 to that in 1998?
Make the answer very short. 1.22. What is the ratio of the Aid flow (current US$) of Angola in 1996 to that in 1998?
Offer a terse response. 0.83. What is the ratio of the Aid flow (current US$) of Mauritania in 1996 to that in 1998?
Offer a very short reply. 1.48. What is the ratio of the Aid flow (current US$) in Morocco in 1996 to that in 1998?
Make the answer very short. 1.15. What is the ratio of the Aid flow (current US$) of Middle income in 1996 to that in 1999?
Offer a very short reply. 1.34. What is the ratio of the Aid flow (current US$) of Angola in 1996 to that in 1999?
Ensure brevity in your answer.  0.71. What is the ratio of the Aid flow (current US$) in Mauritania in 1996 to that in 1999?
Your answer should be compact. 2.65. What is the ratio of the Aid flow (current US$) in Morocco in 1996 to that in 1999?
Make the answer very short. 1.18. What is the ratio of the Aid flow (current US$) in Middle income in 1996 to that in 2000?
Ensure brevity in your answer.  1.54. What is the ratio of the Aid flow (current US$) in Angola in 1996 to that in 2000?
Make the answer very short. 0.6. What is the ratio of the Aid flow (current US$) of Mauritania in 1996 to that in 2000?
Keep it short and to the point. 0.62. What is the ratio of the Aid flow (current US$) in Morocco in 1996 to that in 2000?
Your response must be concise. 0.97. What is the ratio of the Aid flow (current US$) in Middle income in 1996 to that in 2001?
Offer a terse response. 1.55. What is the ratio of the Aid flow (current US$) in Angola in 1996 to that in 2001?
Ensure brevity in your answer.  0.94. What is the ratio of the Aid flow (current US$) in Mauritania in 1996 to that in 2001?
Provide a succinct answer. 1.35. What is the ratio of the Aid flow (current US$) of Morocco in 1996 to that in 2001?
Your answer should be very brief. 1.58. What is the ratio of the Aid flow (current US$) in Middle income in 1997 to that in 1998?
Give a very brief answer. 0.92. What is the ratio of the Aid flow (current US$) in Angola in 1997 to that in 1998?
Offer a very short reply. 1.75. What is the ratio of the Aid flow (current US$) of Mauritania in 1997 to that in 1998?
Provide a succinct answer. 1.8. What is the ratio of the Aid flow (current US$) in Morocco in 1997 to that in 1998?
Offer a very short reply. 1.06. What is the ratio of the Aid flow (current US$) in Middle income in 1997 to that in 1999?
Your answer should be very brief. 1.01. What is the ratio of the Aid flow (current US$) in Angola in 1997 to that in 1999?
Keep it short and to the point. 1.5. What is the ratio of the Aid flow (current US$) in Mauritania in 1997 to that in 1999?
Keep it short and to the point. 3.22. What is the ratio of the Aid flow (current US$) of Morocco in 1997 to that in 1999?
Make the answer very short. 1.09. What is the ratio of the Aid flow (current US$) of Middle income in 1997 to that in 2000?
Ensure brevity in your answer.  1.17. What is the ratio of the Aid flow (current US$) in Angola in 1997 to that in 2000?
Offer a terse response. 1.26. What is the ratio of the Aid flow (current US$) of Mauritania in 1997 to that in 2000?
Your response must be concise. 0.75. What is the ratio of the Aid flow (current US$) of Morocco in 1997 to that in 2000?
Your answer should be very brief. 0.89. What is the ratio of the Aid flow (current US$) of Middle income in 1997 to that in 2001?
Offer a very short reply. 1.17. What is the ratio of the Aid flow (current US$) in Angola in 1997 to that in 2001?
Your answer should be compact. 1.98. What is the ratio of the Aid flow (current US$) of Mauritania in 1997 to that in 2001?
Your answer should be compact. 1.65. What is the ratio of the Aid flow (current US$) in Morocco in 1997 to that in 2001?
Provide a succinct answer. 1.46. What is the ratio of the Aid flow (current US$) of Middle income in 1998 to that in 1999?
Your answer should be compact. 1.1. What is the ratio of the Aid flow (current US$) of Angola in 1998 to that in 1999?
Provide a short and direct response. 0.86. What is the ratio of the Aid flow (current US$) of Mauritania in 1998 to that in 1999?
Your answer should be very brief. 1.8. What is the ratio of the Aid flow (current US$) in Morocco in 1998 to that in 1999?
Provide a short and direct response. 1.02. What is the ratio of the Aid flow (current US$) of Middle income in 1998 to that in 2000?
Offer a terse response. 1.27. What is the ratio of the Aid flow (current US$) of Angola in 1998 to that in 2000?
Offer a terse response. 0.72. What is the ratio of the Aid flow (current US$) of Mauritania in 1998 to that in 2000?
Ensure brevity in your answer.  0.42. What is the ratio of the Aid flow (current US$) of Morocco in 1998 to that in 2000?
Your response must be concise. 0.84. What is the ratio of the Aid flow (current US$) in Middle income in 1998 to that in 2001?
Keep it short and to the point. 1.27. What is the ratio of the Aid flow (current US$) of Angola in 1998 to that in 2001?
Provide a short and direct response. 1.13. What is the ratio of the Aid flow (current US$) of Morocco in 1998 to that in 2001?
Your response must be concise. 1.37. What is the ratio of the Aid flow (current US$) of Middle income in 1999 to that in 2000?
Provide a succinct answer. 1.15. What is the ratio of the Aid flow (current US$) in Angola in 1999 to that in 2000?
Provide a short and direct response. 0.84. What is the ratio of the Aid flow (current US$) in Mauritania in 1999 to that in 2000?
Provide a succinct answer. 0.23. What is the ratio of the Aid flow (current US$) in Morocco in 1999 to that in 2000?
Your response must be concise. 0.82. What is the ratio of the Aid flow (current US$) in Middle income in 1999 to that in 2001?
Give a very brief answer. 1.16. What is the ratio of the Aid flow (current US$) of Angola in 1999 to that in 2001?
Offer a terse response. 1.32. What is the ratio of the Aid flow (current US$) in Mauritania in 1999 to that in 2001?
Your answer should be compact. 0.51. What is the ratio of the Aid flow (current US$) of Morocco in 1999 to that in 2001?
Keep it short and to the point. 1.34. What is the ratio of the Aid flow (current US$) in Middle income in 2000 to that in 2001?
Your response must be concise. 1. What is the ratio of the Aid flow (current US$) in Angola in 2000 to that in 2001?
Ensure brevity in your answer.  1.57. What is the ratio of the Aid flow (current US$) of Mauritania in 2000 to that in 2001?
Provide a short and direct response. 2.19. What is the ratio of the Aid flow (current US$) of Morocco in 2000 to that in 2001?
Your answer should be compact. 1.63. What is the difference between the highest and the second highest Aid flow (current US$) in Middle income?
Your answer should be compact. 4.85e+07. What is the difference between the highest and the second highest Aid flow (current US$) of Angola?
Keep it short and to the point. 7.50e+05. What is the difference between the highest and the second highest Aid flow (current US$) in Mauritania?
Your answer should be very brief. 5.20e+05. What is the difference between the highest and the second highest Aid flow (current US$) in Morocco?
Provide a short and direct response. 1.83e+06. What is the difference between the highest and the lowest Aid flow (current US$) of Middle income?
Make the answer very short. 1.88e+08. What is the difference between the highest and the lowest Aid flow (current US$) in Angola?
Offer a terse response. 2.42e+06. What is the difference between the highest and the lowest Aid flow (current US$) in Mauritania?
Offer a very short reply. 1.61e+06. What is the difference between the highest and the lowest Aid flow (current US$) in Morocco?
Give a very brief answer. 3.84e+06. 